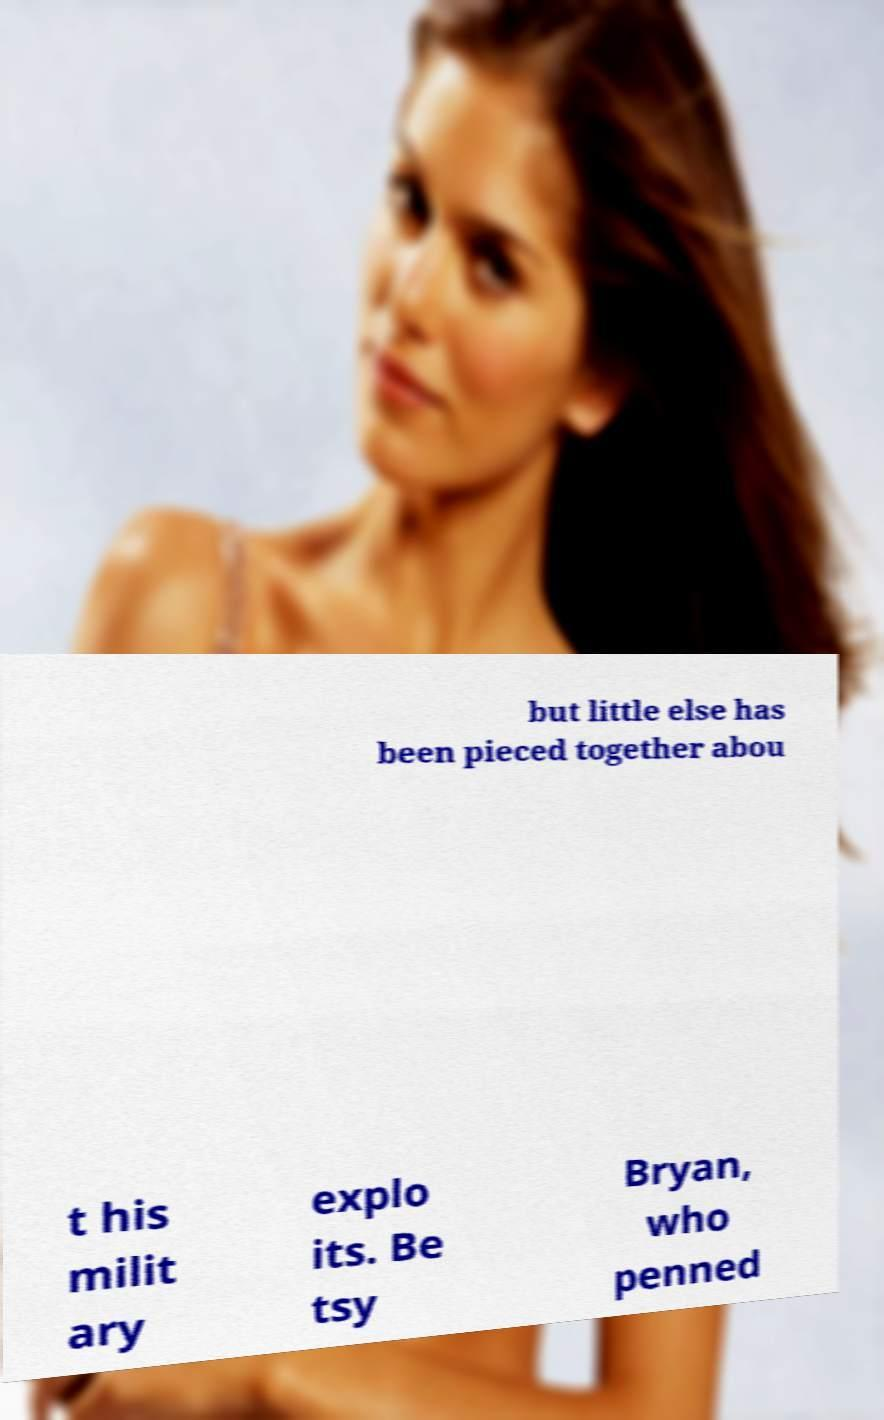There's text embedded in this image that I need extracted. Can you transcribe it verbatim? but little else has been pieced together abou t his milit ary explo its. Be tsy Bryan, who penned 